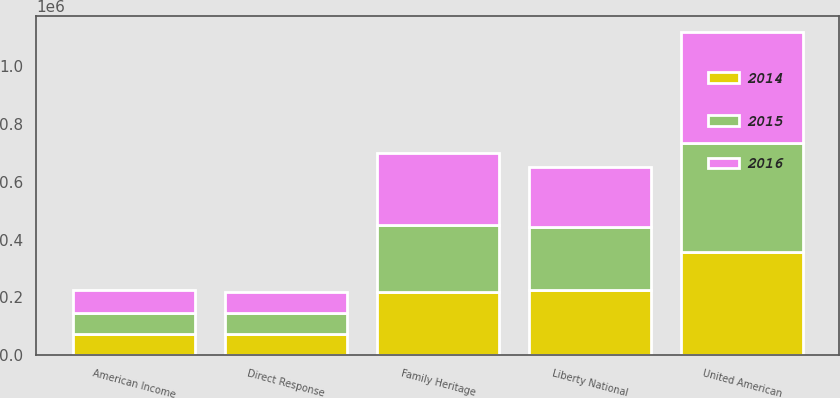<chart> <loc_0><loc_0><loc_500><loc_500><stacked_bar_chart><ecel><fcel>Direct Response<fcel>Liberty National<fcel>American Income<fcel>Family Heritage<fcel>United American<nl><fcel>2016<fcel>74261<fcel>210260<fcel>78947<fcel>249857<fcel>385309<nl><fcel>2015<fcel>72423<fcel>216139<fcel>74058<fcel>234120<fcel>376302<nl><fcel>2014<fcel>72659<fcel>226599<fcel>71942<fcel>217742<fcel>358381<nl></chart> 